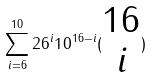Convert formula to latex. <formula><loc_0><loc_0><loc_500><loc_500>\sum _ { i = 6 } ^ { 1 0 } 2 6 ^ { i } 1 0 ^ { 1 6 - i } ( \begin{matrix} 1 6 \\ i \end{matrix} )</formula> 